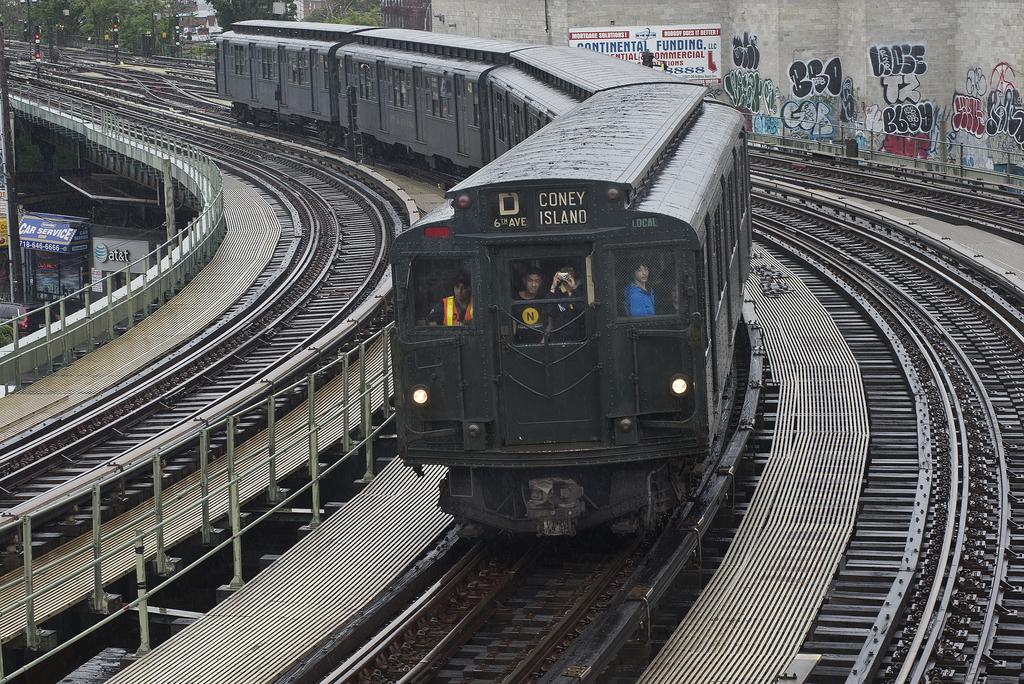What does the green bin say on the front?
Your response must be concise. Coney island. What island is named?
Offer a terse response. Coney. 